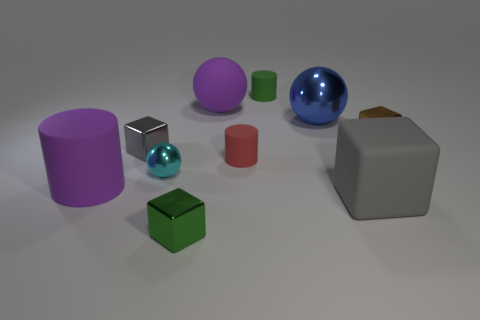Is the color of the large matte cylinder the same as the matte ball?
Provide a succinct answer. Yes. Is the number of small things behind the cyan metallic thing greater than the number of small cylinders that are to the left of the small green matte thing?
Offer a terse response. Yes. The tiny metallic cube in front of the purple thing left of the cyan metallic object is what color?
Offer a very short reply. Green. Are the big purple cylinder and the large blue ball made of the same material?
Ensure brevity in your answer.  No. Is there a big gray thing of the same shape as the small gray metallic object?
Your response must be concise. Yes. There is a matte cylinder in front of the red matte cylinder; does it have the same color as the rubber ball?
Make the answer very short. Yes. There is a metal thing to the right of the gray matte cube; is its size the same as the shiny object that is behind the tiny brown metal thing?
Offer a very short reply. No. There is a sphere that is the same material as the tiny red thing; what size is it?
Provide a succinct answer. Large. What number of big matte things are in front of the red matte cylinder and behind the rubber block?
Ensure brevity in your answer.  1. What number of objects are small rubber objects or big things in front of the tiny brown metallic object?
Give a very brief answer. 4. 